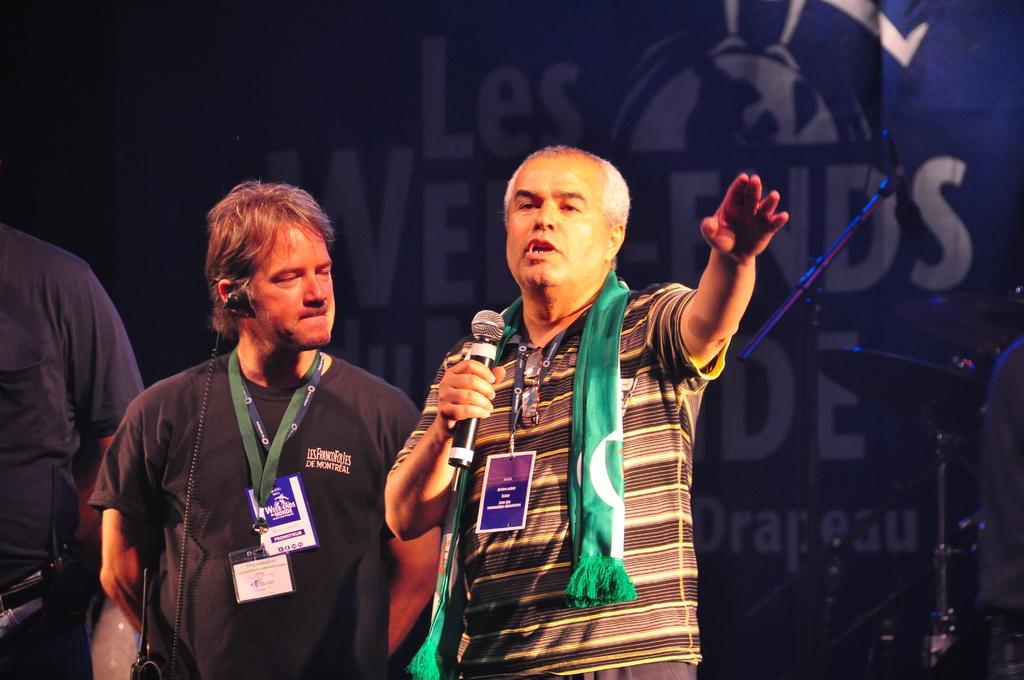Describe this image in one or two sentences. In the image there are three people and the first person is speaking something, behind them there is a banner and in front of the banner there are some objects. 